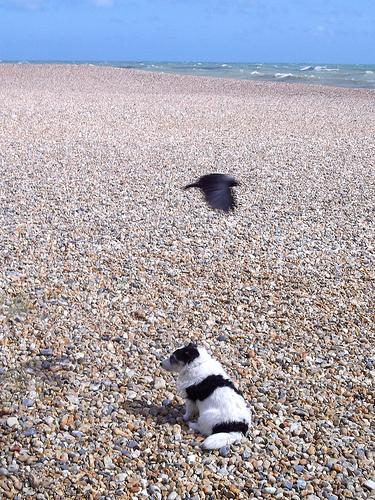Narrate a story using the objects in this image. Once upon a time, on a picturesque rocky shore, a black and white dog sat among the rocks, enjoying the cool breeze. While watching the waves dance and crash, a black bird flew over, catching the dog's attention, but the dog remained calm and undisturbed in its serene surroundings. Provide a short poem using the different elements found in the image. As a black bird above gracefully soared. In this scenario, predict the possible outcome of the interaction between the dog and the bird. The black bird, caught in its own world, may continue flying above the rocks, while the black and white dog might remain seated, nonchalantly watching but not engaging with the bird. List down the colors present in the image. Blue, white, black, brown, and various shades of gray are present in the image, representing the sky, ocean, dog, pebbles, rocks, and bird. Describe the emotions this image might evoke in a viewer. This image may evoke a sense of tranquility and calmness, as they observe a peaceful moment between a dog sitting on a rocky, pebble-covered beach, the black bird flying above, and the mesmerizing ocean waves in the distance. Give a brief overview of the objects and entities present in the image. The image contains a black and white dog sitting on a rocky beach, a black bird flying above, colorful pebbles around, and the blue ocean with small waves in the background. Analyze the interaction between two significant subjects in the image. What conclusions can you draw? The interaction between the black and white dog and the black bird is relatively passive. The dog, while not actively engaging with the bird, is aware of its presence. It is plausible that both animals coexist peacefully in their respective domains. Enumerate and briefly assess the quality of the image for each object in the scene. 5. Sky - bright and wide-ranging, of good quality. Help one of the objects complete their primary objective by explaining the first three steps boldly. To help the black bird catch a fish from the water, it must 1) Increase its altitude to get a better view; 2) Scan the ocean surface for movement indicating fish presence; 3) Swiftly dive downward to snatch the fish once spotted. Based on the image, count and describe the distinguishing features of the dog and the bird. The dog has two distinguishing features: a) its black and white fur, and b) it is sitting among the rocks. The bird has three distinguishing features: a) it is black, b) it has a black tail, and c) it is flying slightly blurry in mid-flight. Can you see a red bird in the image? No, it's not mentioned in the image. 